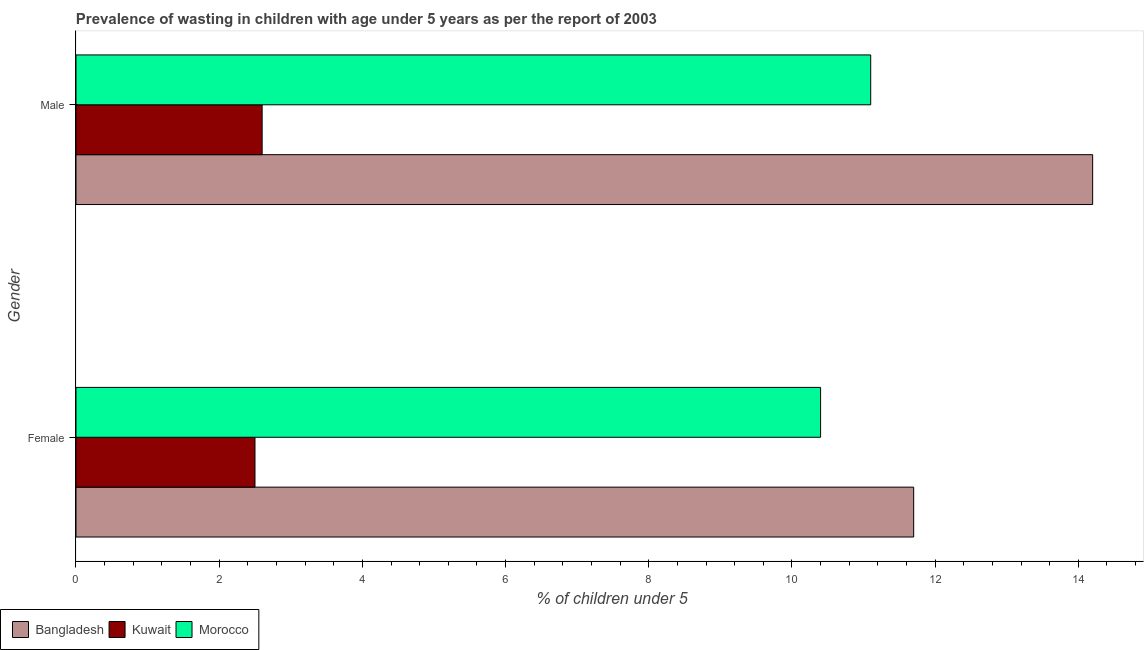Are the number of bars per tick equal to the number of legend labels?
Keep it short and to the point. Yes. How many bars are there on the 1st tick from the top?
Your answer should be very brief. 3. How many bars are there on the 2nd tick from the bottom?
Provide a succinct answer. 3. What is the label of the 1st group of bars from the top?
Your answer should be very brief. Male. What is the percentage of undernourished male children in Morocco?
Your answer should be compact. 11.1. Across all countries, what is the maximum percentage of undernourished female children?
Provide a short and direct response. 11.7. In which country was the percentage of undernourished female children minimum?
Your response must be concise. Kuwait. What is the total percentage of undernourished male children in the graph?
Make the answer very short. 27.9. What is the difference between the percentage of undernourished male children in Kuwait and that in Bangladesh?
Make the answer very short. -11.6. What is the difference between the percentage of undernourished female children in Morocco and the percentage of undernourished male children in Bangladesh?
Ensure brevity in your answer.  -3.8. What is the average percentage of undernourished male children per country?
Your response must be concise. 9.3. In how many countries, is the percentage of undernourished male children greater than 13.2 %?
Your response must be concise. 1. What is the ratio of the percentage of undernourished female children in Kuwait to that in Bangladesh?
Offer a terse response. 0.21. What does the 3rd bar from the top in Female represents?
Your answer should be very brief. Bangladesh. What does the 3rd bar from the bottom in Male represents?
Give a very brief answer. Morocco. Are all the bars in the graph horizontal?
Keep it short and to the point. Yes. What is the difference between two consecutive major ticks on the X-axis?
Keep it short and to the point. 2. What is the title of the graph?
Keep it short and to the point. Prevalence of wasting in children with age under 5 years as per the report of 2003. What is the label or title of the X-axis?
Your answer should be very brief.  % of children under 5. What is the  % of children under 5 in Bangladesh in Female?
Provide a short and direct response. 11.7. What is the  % of children under 5 in Morocco in Female?
Make the answer very short. 10.4. What is the  % of children under 5 in Bangladesh in Male?
Provide a succinct answer. 14.2. What is the  % of children under 5 of Kuwait in Male?
Offer a very short reply. 2.6. What is the  % of children under 5 in Morocco in Male?
Provide a short and direct response. 11.1. Across all Gender, what is the maximum  % of children under 5 of Bangladesh?
Provide a succinct answer. 14.2. Across all Gender, what is the maximum  % of children under 5 in Kuwait?
Ensure brevity in your answer.  2.6. Across all Gender, what is the maximum  % of children under 5 of Morocco?
Give a very brief answer. 11.1. Across all Gender, what is the minimum  % of children under 5 of Bangladesh?
Offer a very short reply. 11.7. Across all Gender, what is the minimum  % of children under 5 of Morocco?
Give a very brief answer. 10.4. What is the total  % of children under 5 of Bangladesh in the graph?
Ensure brevity in your answer.  25.9. What is the total  % of children under 5 of Kuwait in the graph?
Your answer should be compact. 5.1. What is the difference between the  % of children under 5 in Bangladesh in Female and that in Male?
Your response must be concise. -2.5. What is the difference between the  % of children under 5 of Morocco in Female and that in Male?
Make the answer very short. -0.7. What is the difference between the  % of children under 5 of Bangladesh in Female and the  % of children under 5 of Kuwait in Male?
Your response must be concise. 9.1. What is the difference between the  % of children under 5 in Kuwait in Female and the  % of children under 5 in Morocco in Male?
Your response must be concise. -8.6. What is the average  % of children under 5 of Bangladesh per Gender?
Offer a very short reply. 12.95. What is the average  % of children under 5 in Kuwait per Gender?
Your answer should be compact. 2.55. What is the average  % of children under 5 of Morocco per Gender?
Offer a very short reply. 10.75. What is the difference between the  % of children under 5 in Bangladesh and  % of children under 5 in Kuwait in Female?
Provide a short and direct response. 9.2. What is the difference between the  % of children under 5 of Bangladesh and  % of children under 5 of Morocco in Female?
Make the answer very short. 1.3. What is the difference between the  % of children under 5 of Kuwait and  % of children under 5 of Morocco in Female?
Provide a short and direct response. -7.9. What is the ratio of the  % of children under 5 in Bangladesh in Female to that in Male?
Offer a terse response. 0.82. What is the ratio of the  % of children under 5 of Kuwait in Female to that in Male?
Offer a terse response. 0.96. What is the ratio of the  % of children under 5 of Morocco in Female to that in Male?
Offer a terse response. 0.94. What is the difference between the highest and the lowest  % of children under 5 in Bangladesh?
Offer a terse response. 2.5. What is the difference between the highest and the lowest  % of children under 5 of Kuwait?
Your answer should be very brief. 0.1. What is the difference between the highest and the lowest  % of children under 5 in Morocco?
Provide a succinct answer. 0.7. 